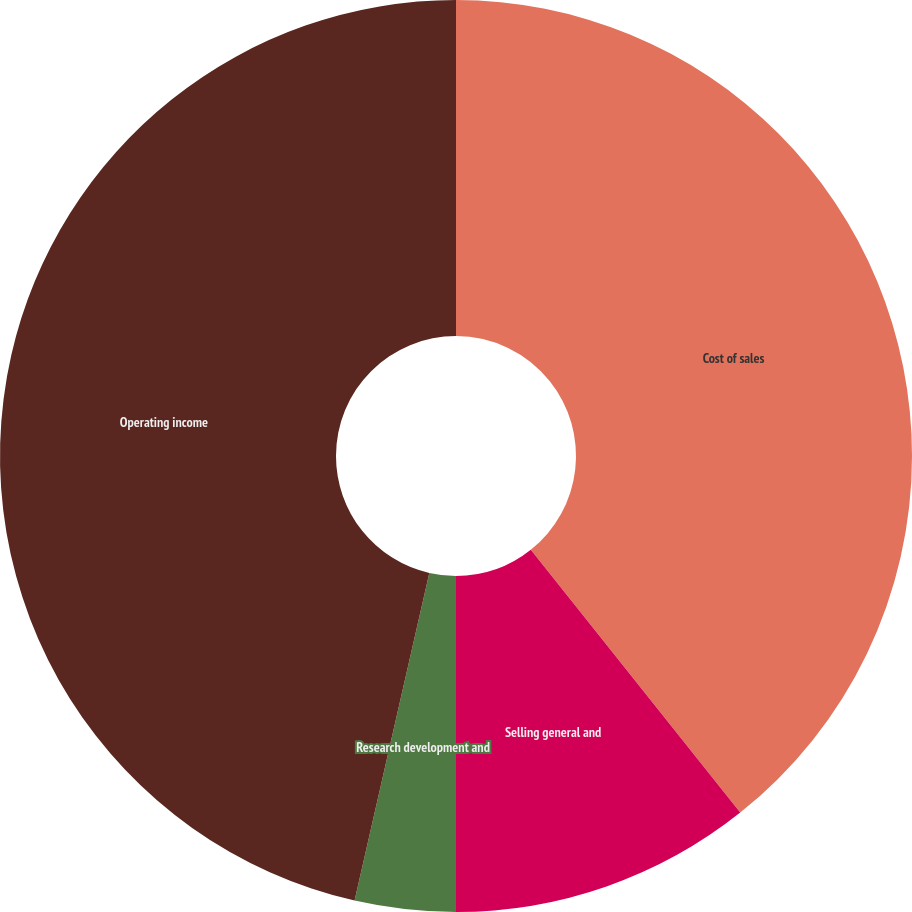Convert chart to OTSL. <chart><loc_0><loc_0><loc_500><loc_500><pie_chart><fcel>Cost of sales<fcel>Selling general and<fcel>Research development and<fcel>Operating income<nl><fcel>39.29%<fcel>10.71%<fcel>3.57%<fcel>46.43%<nl></chart> 